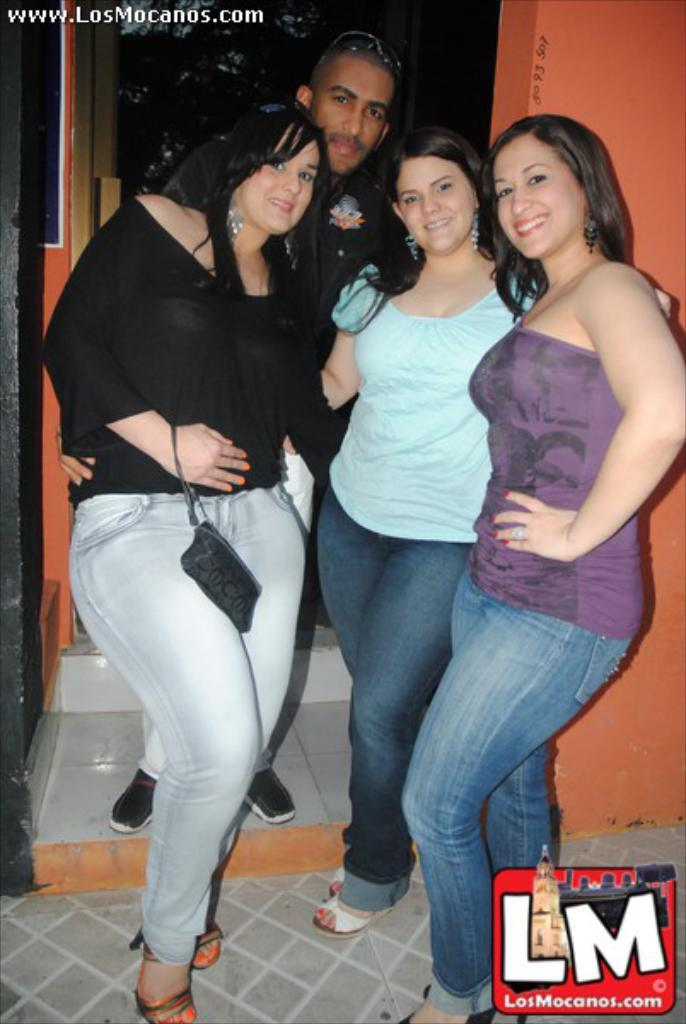How many people are in the image? There is a group of people in the image, but the exact number is not specified. What can be seen on the right side of the image? There is a wall on the right side of the image. What type of account is being discussed by the people in the image? There is no indication in the image that the people are discussing any type of account. How many nails are visible in the image? There is no mention of nails in the image, so it is not possible to determine how many are visible. 